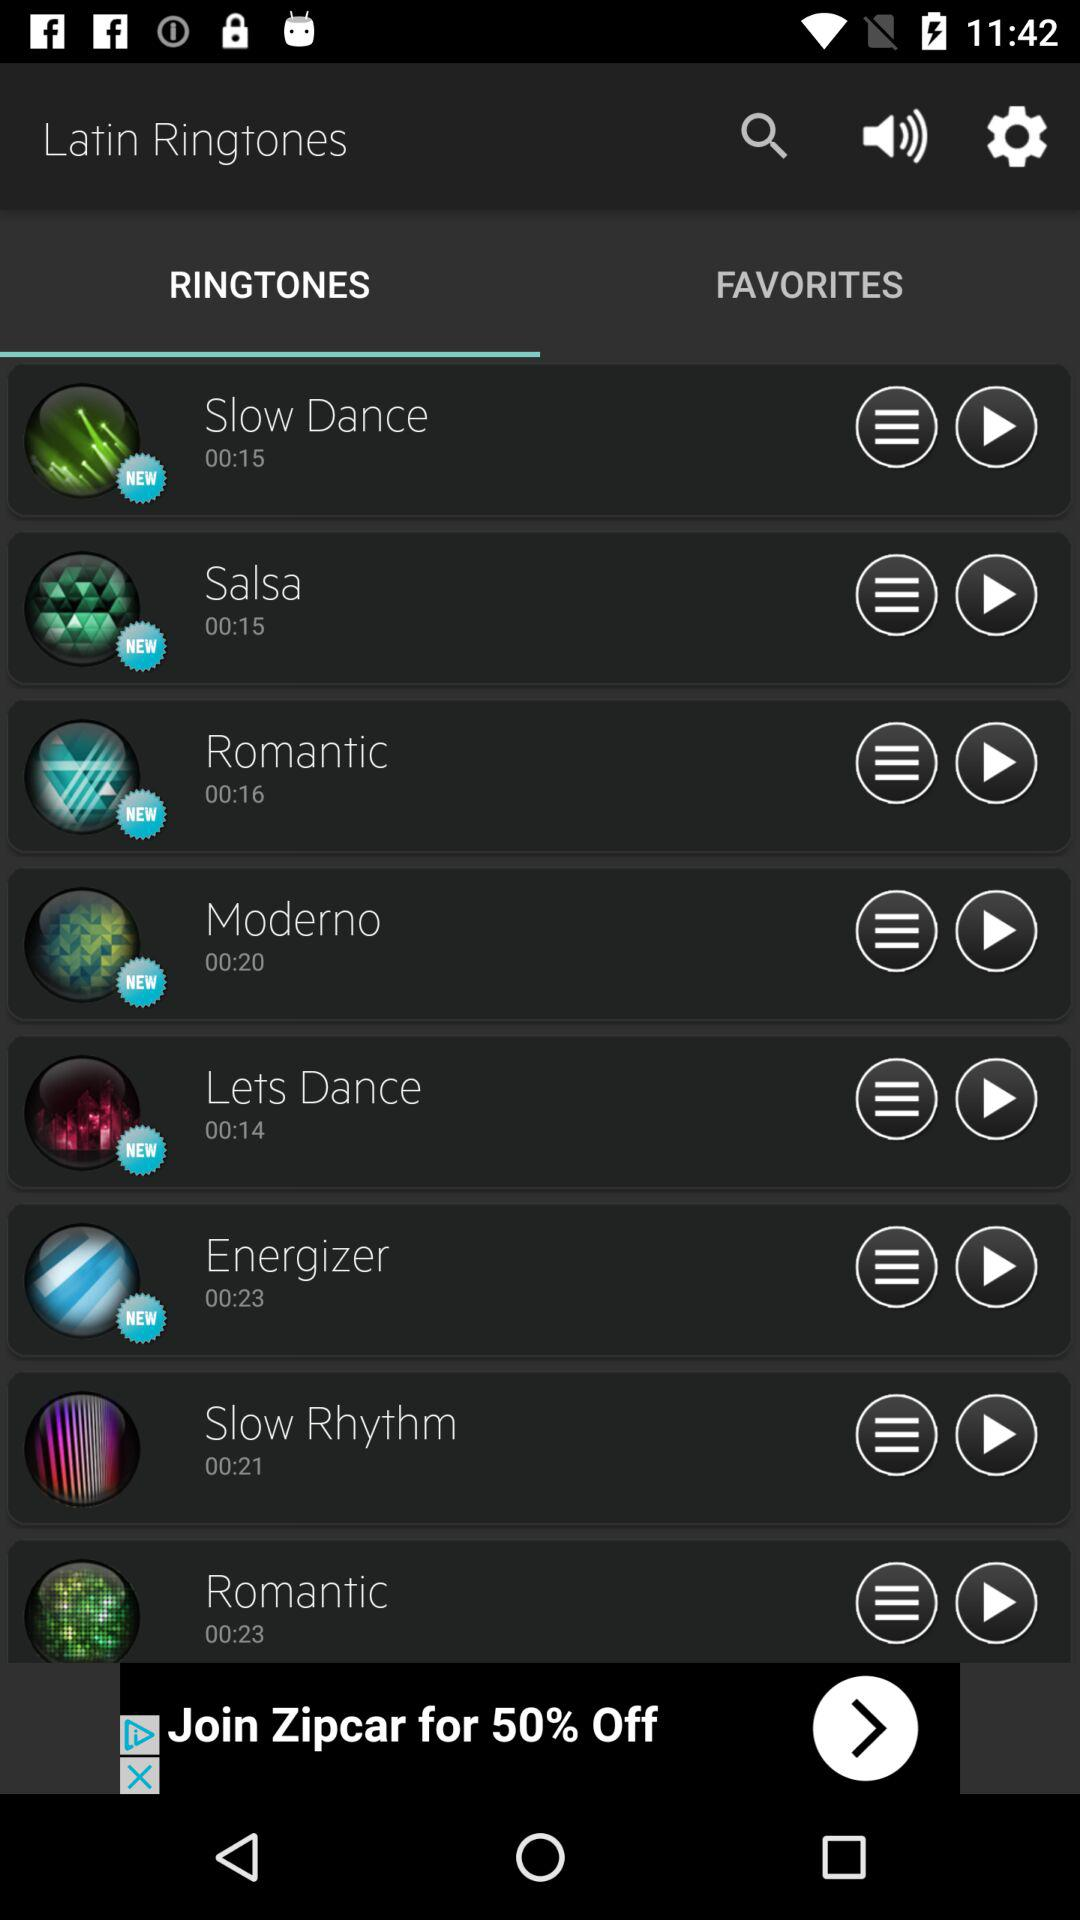Which option is selected for "Latin Ringtones"? The option is "RINGTONES". 